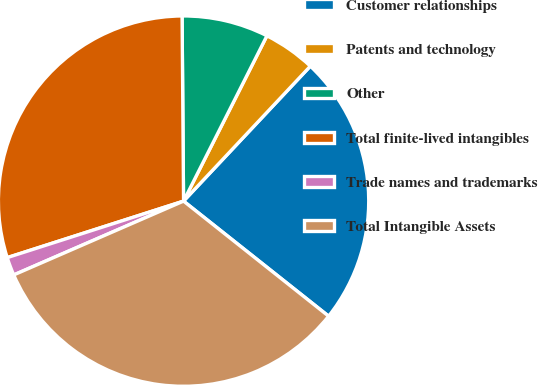Convert chart to OTSL. <chart><loc_0><loc_0><loc_500><loc_500><pie_chart><fcel>Customer relationships<fcel>Patents and technology<fcel>Other<fcel>Total finite-lived intangibles<fcel>Trade names and trademarks<fcel>Total Intangible Assets<nl><fcel>23.67%<fcel>4.57%<fcel>7.56%<fcel>29.81%<fcel>1.59%<fcel>32.8%<nl></chart> 